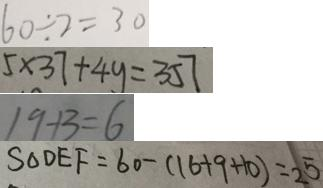<formula> <loc_0><loc_0><loc_500><loc_500>6 0 \div 2 = 3 0 
 5 \times 3 7 + 4 y = 3 5 7 
 1 9 + 3 = 6 
 S _ { \Delta D E F } = 6 0 - ( 1 6 + 9 + 1 0 ) = 2 5</formula> 